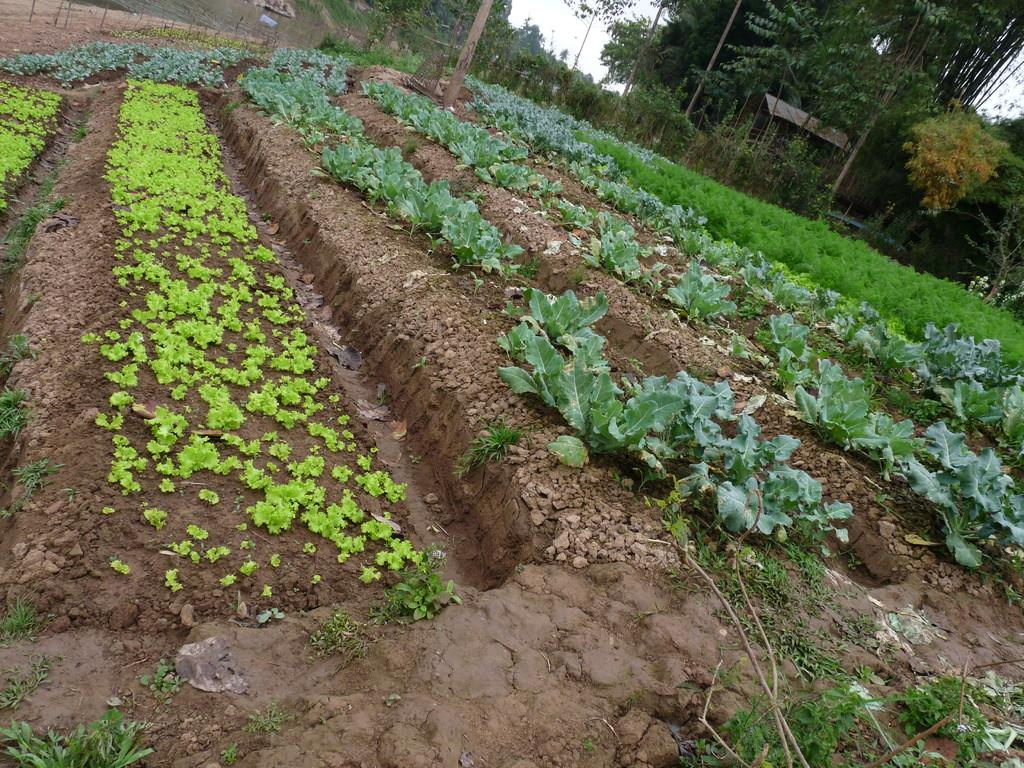What type of terrain is depicted in the image? The image contains mud, grass, plants, and sand. What type of vegetation can be seen in the image? There are grass and plants in the image. What is visible in the background of the image? There are trees in the background of the image. What part of the natural environment is visible in the image? The sky is visible in the image. Can you see a match being lit in the image? There is no match or any indication of fire in the image. What type of sink is visible in the image? There is no sink present in the image. 